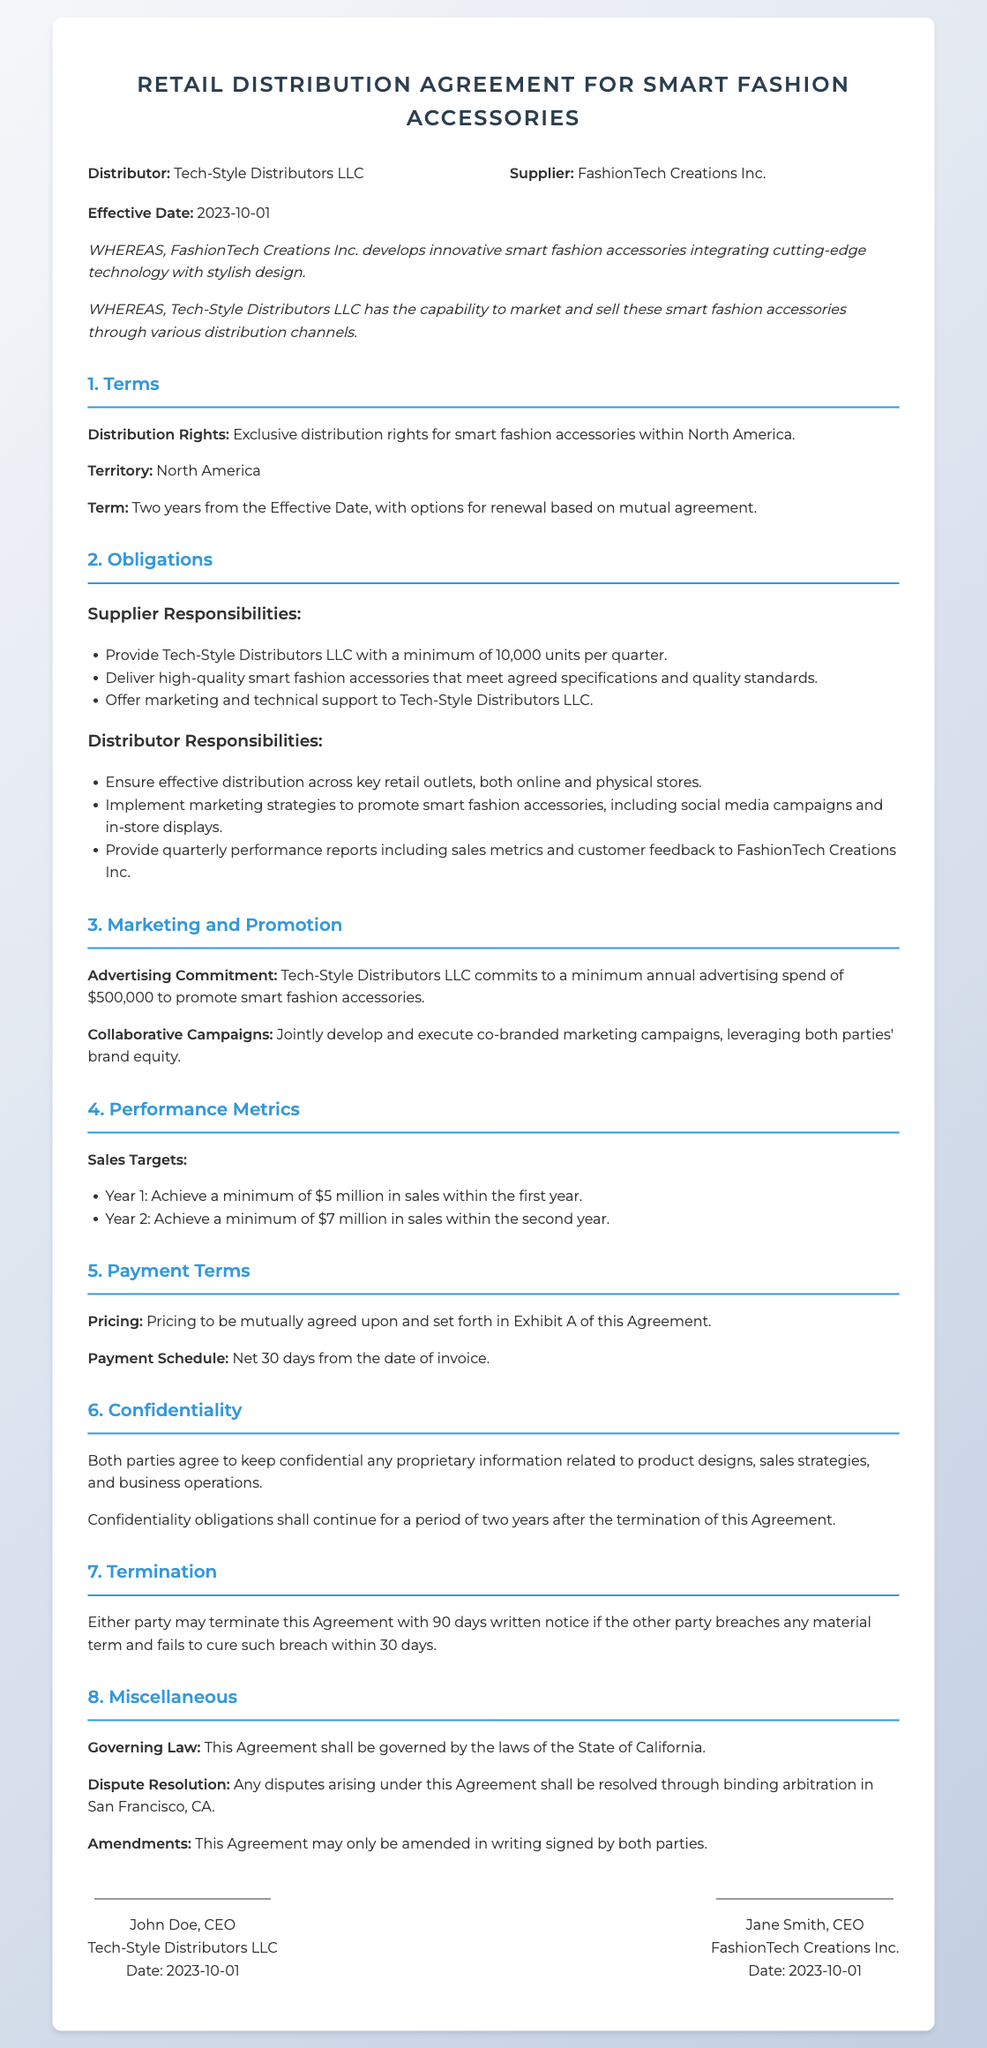What is the effective date of the agreement? The effective date is stated at the beginning of the document, marking when the agreement starts.
Answer: 2023-10-01 Who is the supplier in this agreement? The supplier is defined at the beginning of the document, identifying the entity responsible for providing the products.
Answer: FashionTech Creations Inc What are the sales targets for Year 1? The document specifies minimum sales targets for each year, outlining performance expectations for the distributor.
Answer: $5 million What is the minimum annual advertising spend? The advertising commitment section outlines the financial obligation for marketing efforts specified in the agreement.
Answer: $500,000 How long is the term of this agreement? The term section provides the duration of the agreement, indicating how long the distribution rights will be effective.
Answer: Two years What are the confidentiality obligations duration after termination? The confidentiality section highlights how long the proprietary information must remain confidential, indicating the duration specified.
Answer: Two years What must the distributor provide quarterly to the supplier? The distributor's responsibilities section describes what performance information is required to be reported to the supplier regularly.
Answer: Quarterly performance reports What is the governing law for this agreement? The miscellaneous section indicates which state laws will apply to resolve any legal issues arising from this agreement.
Answer: California 